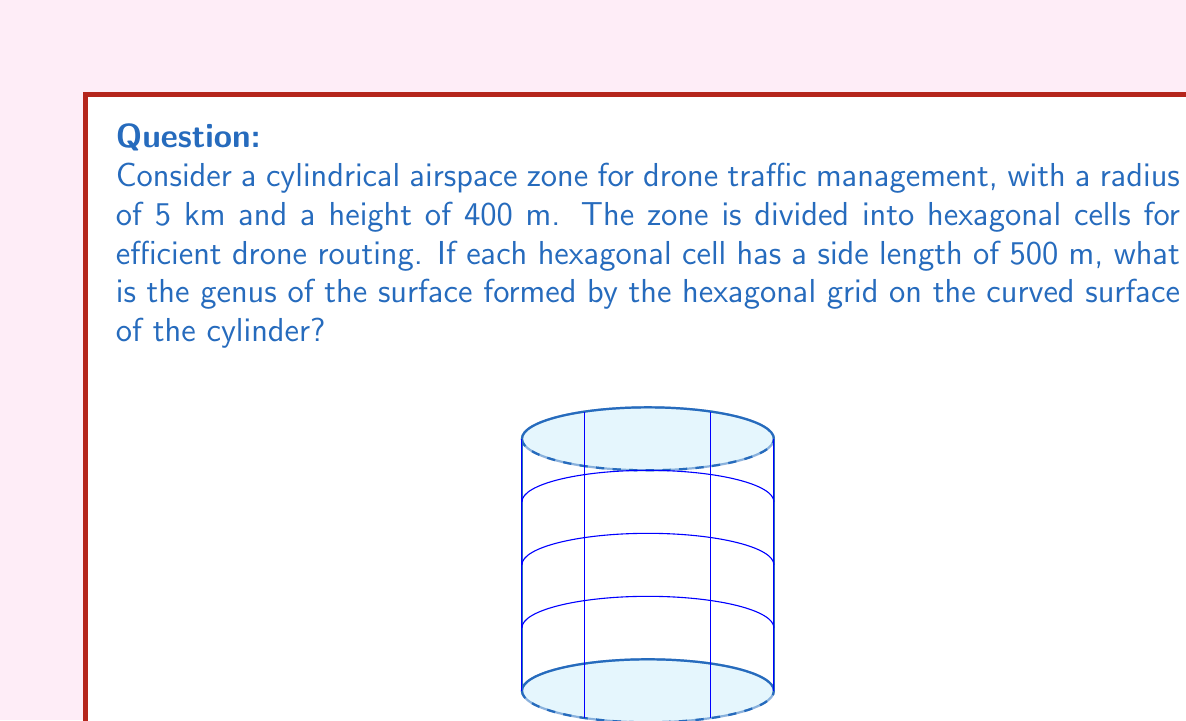Can you solve this math problem? To solve this problem, we need to follow these steps:

1) First, we need to calculate the number of hexagonal cells on the surface of the cylinder.

   Circumference of the cylinder = $2\pi r = 2\pi \cdot 5 = 10\pi$ km
   Number of cells around the circumference = $10\pi / (0.5\sqrt{3}) \approx 36.22$
   We round this down to 36 cells to ensure they fit.

   Height of the cylinder = 400 m = 0.4 km
   Number of cells vertically = $0.4 / (0.5 \cdot \frac{\sqrt{3}}{2}) \approx 1.85$
   We round this up to 2 cells to cover the entire height.

   Total number of cells = $36 \cdot 2 = 72$

2) Now, we need to calculate the Euler characteristic ($\chi$) of this surface.
   
   Vertices (V) = Number of cell corners
   Edges (E) = Number of cell sides
   Faces (F) = Number of cells

   $V = 36 \cdot 2 = 72$ (each vertical line of hexagons shares vertices)
   $E = 36 \cdot 3 + 36 \cdot 2 = 180$ (3 new edges per cell in first row, 2 in second)
   $F = 72$

   $\chi = V - E + F = 72 - 180 + 72 = -36$

3) For a closed orientable surface, the Euler characteristic is related to the genus (g) by the formula:

   $\chi = 2 - 2g$

4) Solving for g:

   $-36 = 2 - 2g$
   $-38 = -2g$
   $g = 19$

Therefore, the genus of the surface is 19.
Answer: 19 